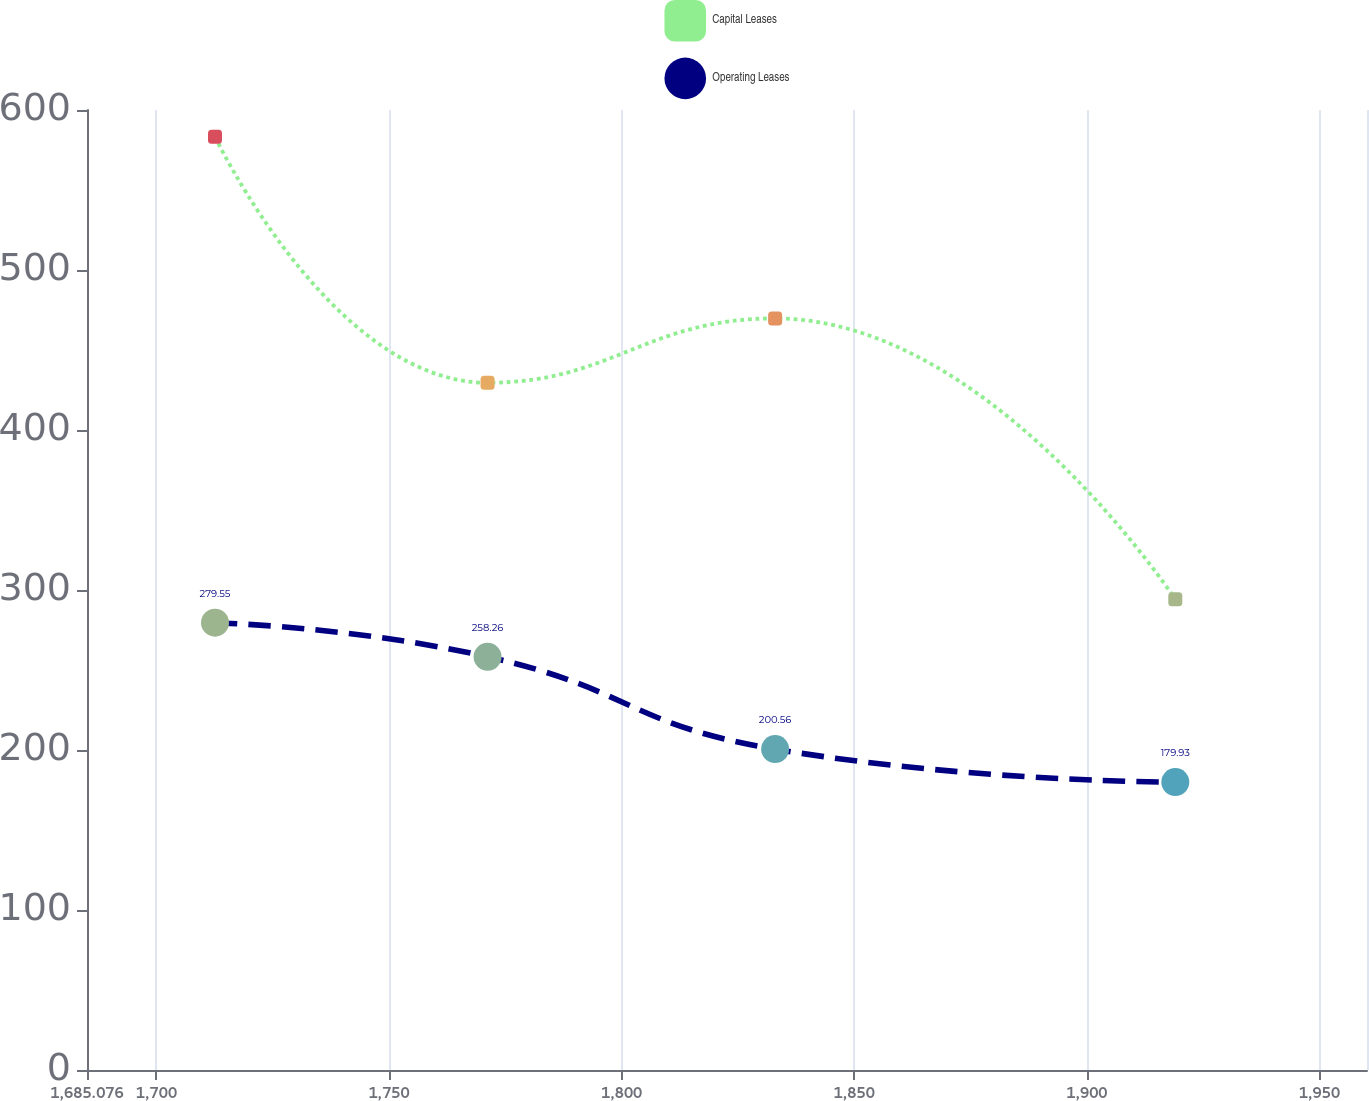<chart> <loc_0><loc_0><loc_500><loc_500><line_chart><ecel><fcel>Capital Leases<fcel>Operating Leases<nl><fcel>1712.59<fcel>583.33<fcel>279.55<nl><fcel>1771.18<fcel>429.53<fcel>258.26<nl><fcel>1832.99<fcel>469.74<fcel>200.56<nl><fcel>1919.01<fcel>294.18<fcel>179.93<nl><fcel>1987.73<fcel>323.1<fcel>210.52<nl></chart> 